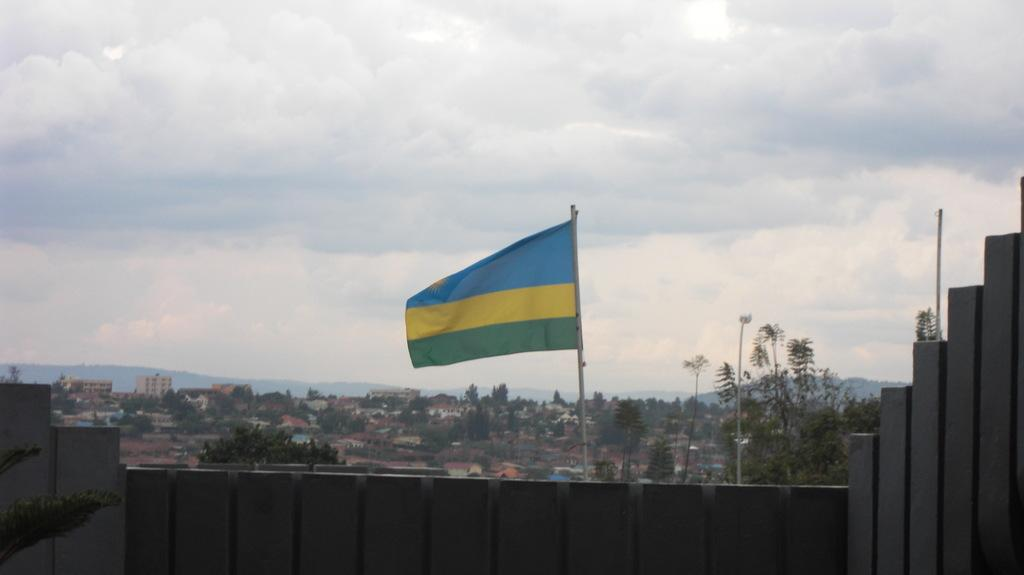What is the main object in the image? There is a flag in the image. What else can be seen in the image besides the flag? There are trees and buildings in the image. What is visible in the sky in the image? Clouds are visible in the sky in the image. How many dimes are placed on the flag in the image? There are no dimes present in the image; the flag is the main object. 